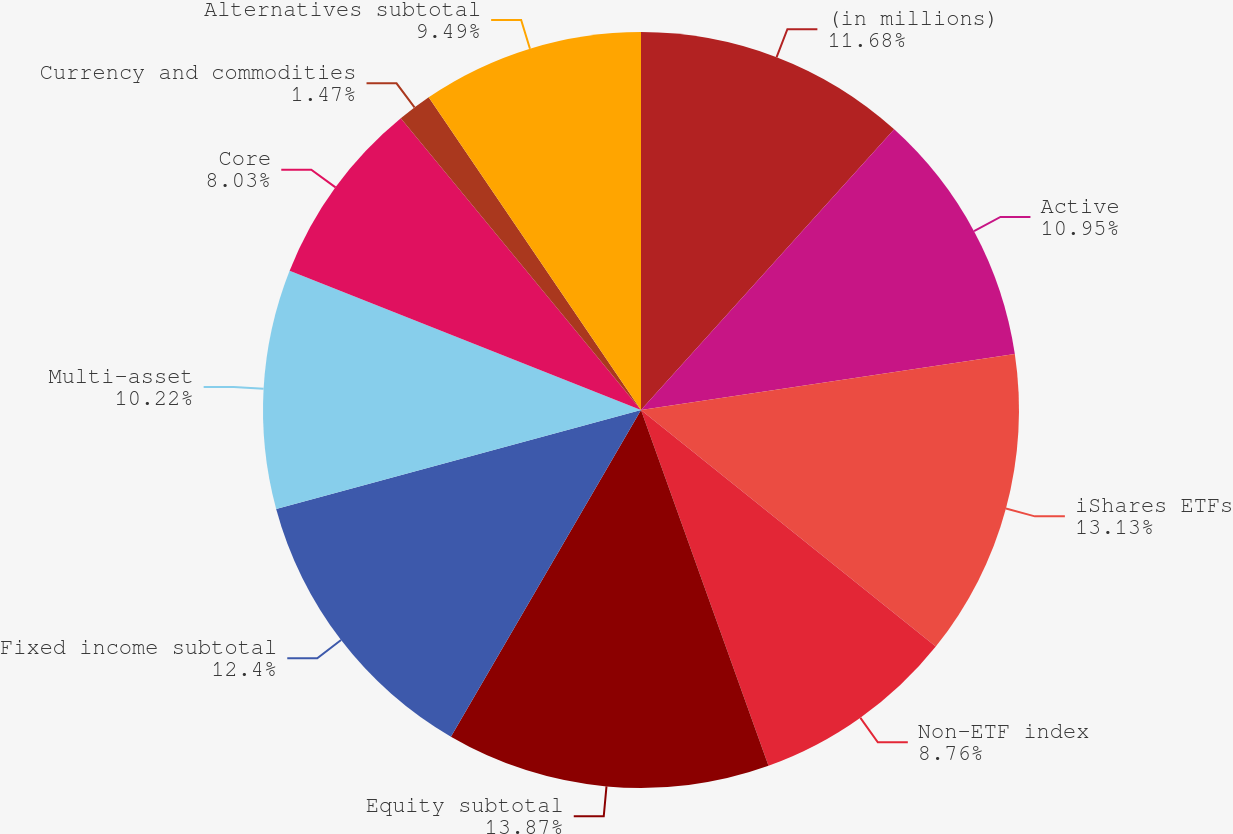Convert chart. <chart><loc_0><loc_0><loc_500><loc_500><pie_chart><fcel>(in millions)<fcel>Active<fcel>iShares ETFs<fcel>Non-ETF index<fcel>Equity subtotal<fcel>Fixed income subtotal<fcel>Multi-asset<fcel>Core<fcel>Currency and commodities<fcel>Alternatives subtotal<nl><fcel>11.68%<fcel>10.95%<fcel>13.13%<fcel>8.76%<fcel>13.86%<fcel>12.4%<fcel>10.22%<fcel>8.03%<fcel>1.47%<fcel>9.49%<nl></chart> 